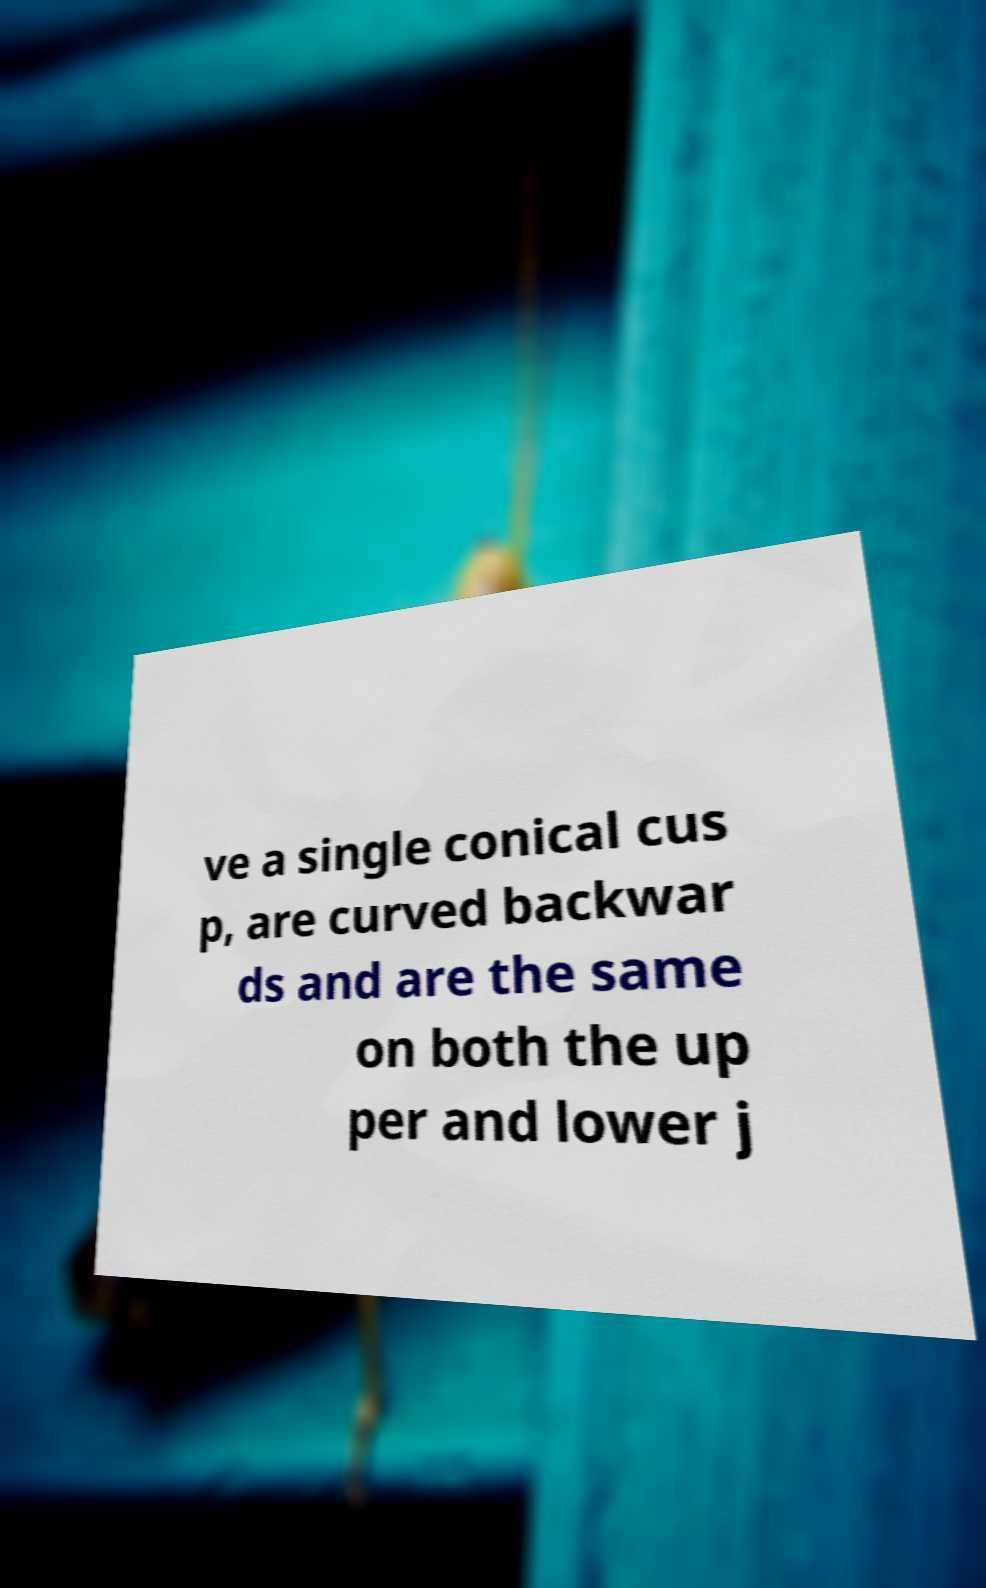Can you accurately transcribe the text from the provided image for me? ve a single conical cus p, are curved backwar ds and are the same on both the up per and lower j 